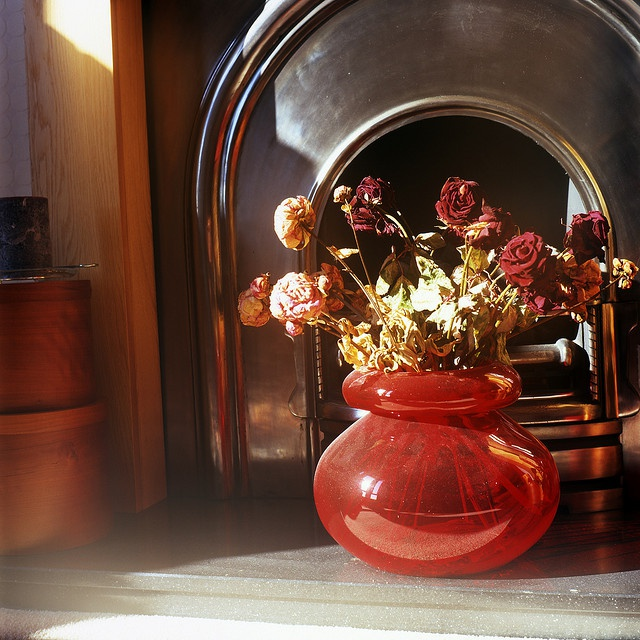Describe the objects in this image and their specific colors. I can see a vase in gray, brown, maroon, and salmon tones in this image. 